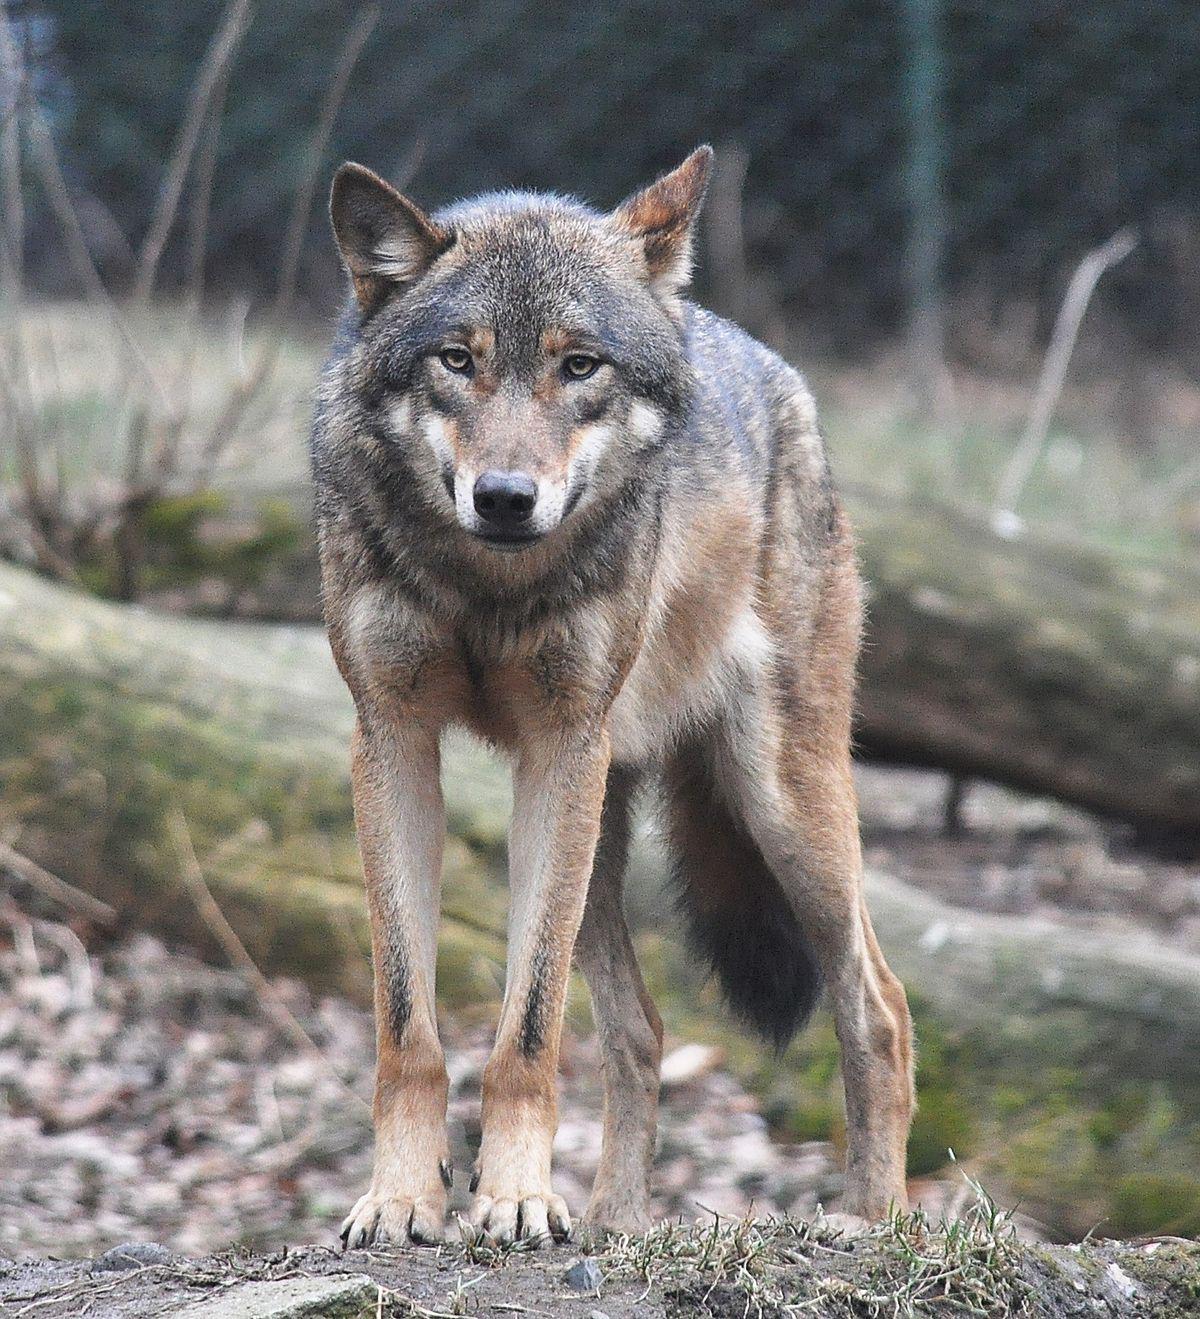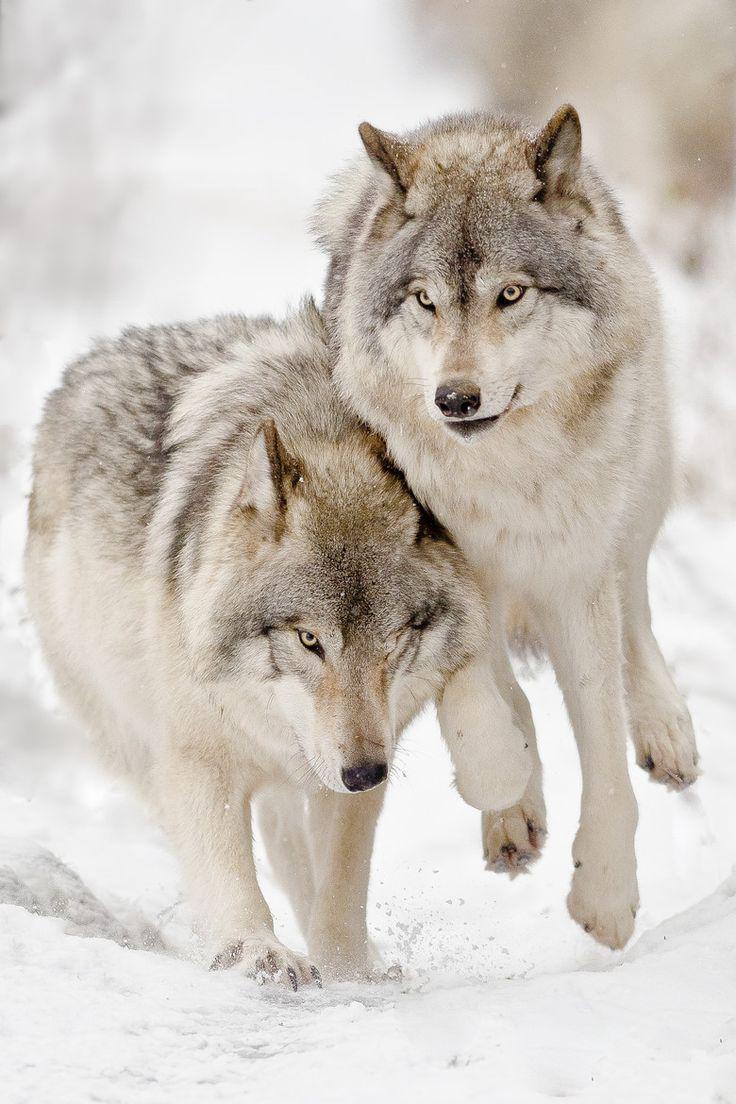The first image is the image on the left, the second image is the image on the right. Assess this claim about the two images: "One image shows a single wolf carrying something in its mouth.". Correct or not? Answer yes or no. No. The first image is the image on the left, the second image is the image on the right. Considering the images on both sides, is "There are exactly three wolves out doors." valid? Answer yes or no. Yes. 